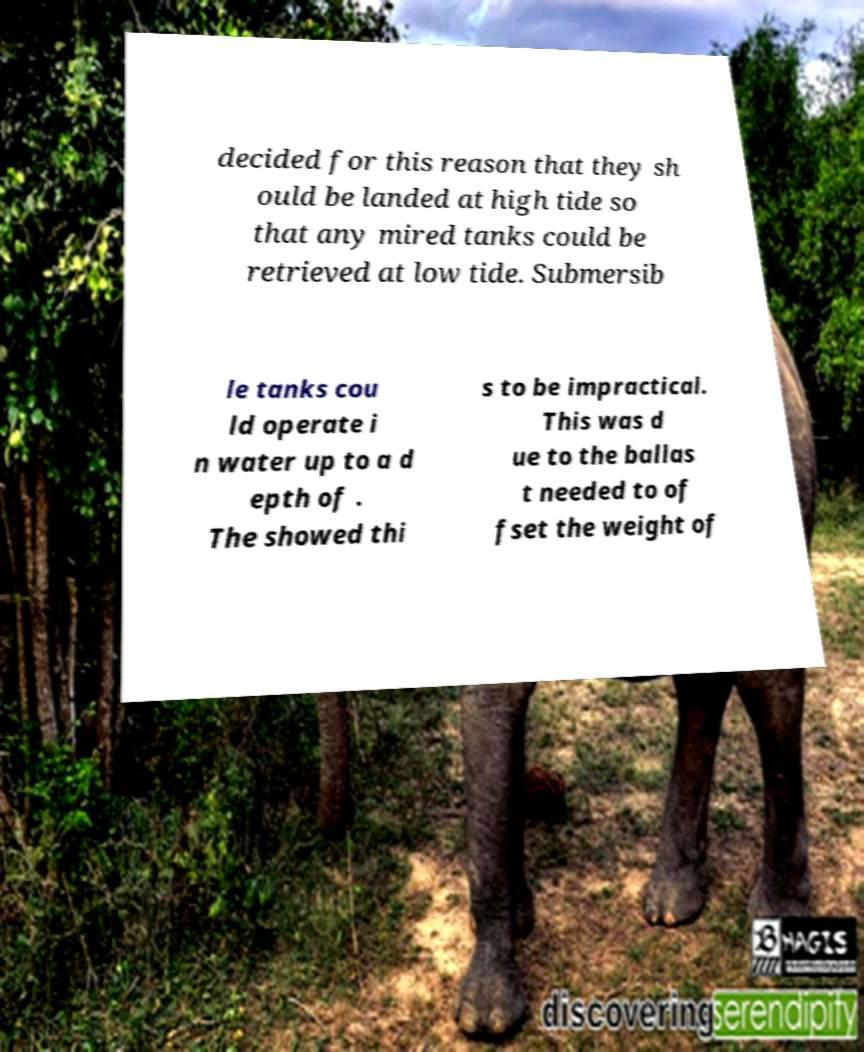What messages or text are displayed in this image? I need them in a readable, typed format. decided for this reason that they sh ould be landed at high tide so that any mired tanks could be retrieved at low tide. Submersib le tanks cou ld operate i n water up to a d epth of . The showed thi s to be impractical. This was d ue to the ballas t needed to of fset the weight of 